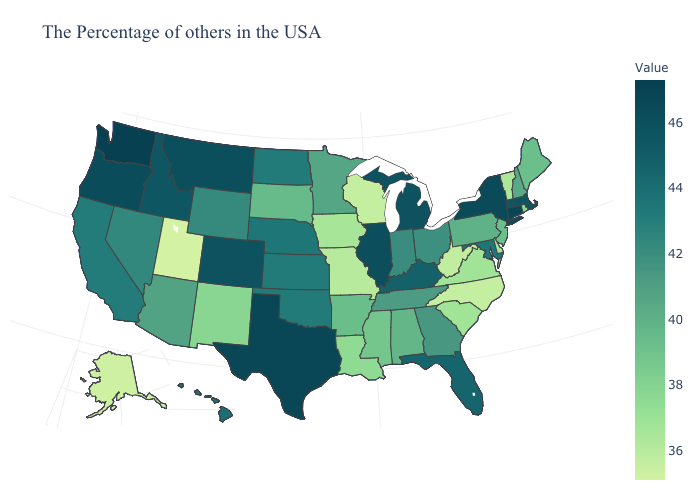Which states have the lowest value in the West?
Short answer required. Utah. Among the states that border Louisiana , does Mississippi have the lowest value?
Quick response, please. Yes. Does Washington have the highest value in the USA?
Quick response, please. Yes. Is the legend a continuous bar?
Concise answer only. Yes. Does Utah have the lowest value in the USA?
Be succinct. Yes. 